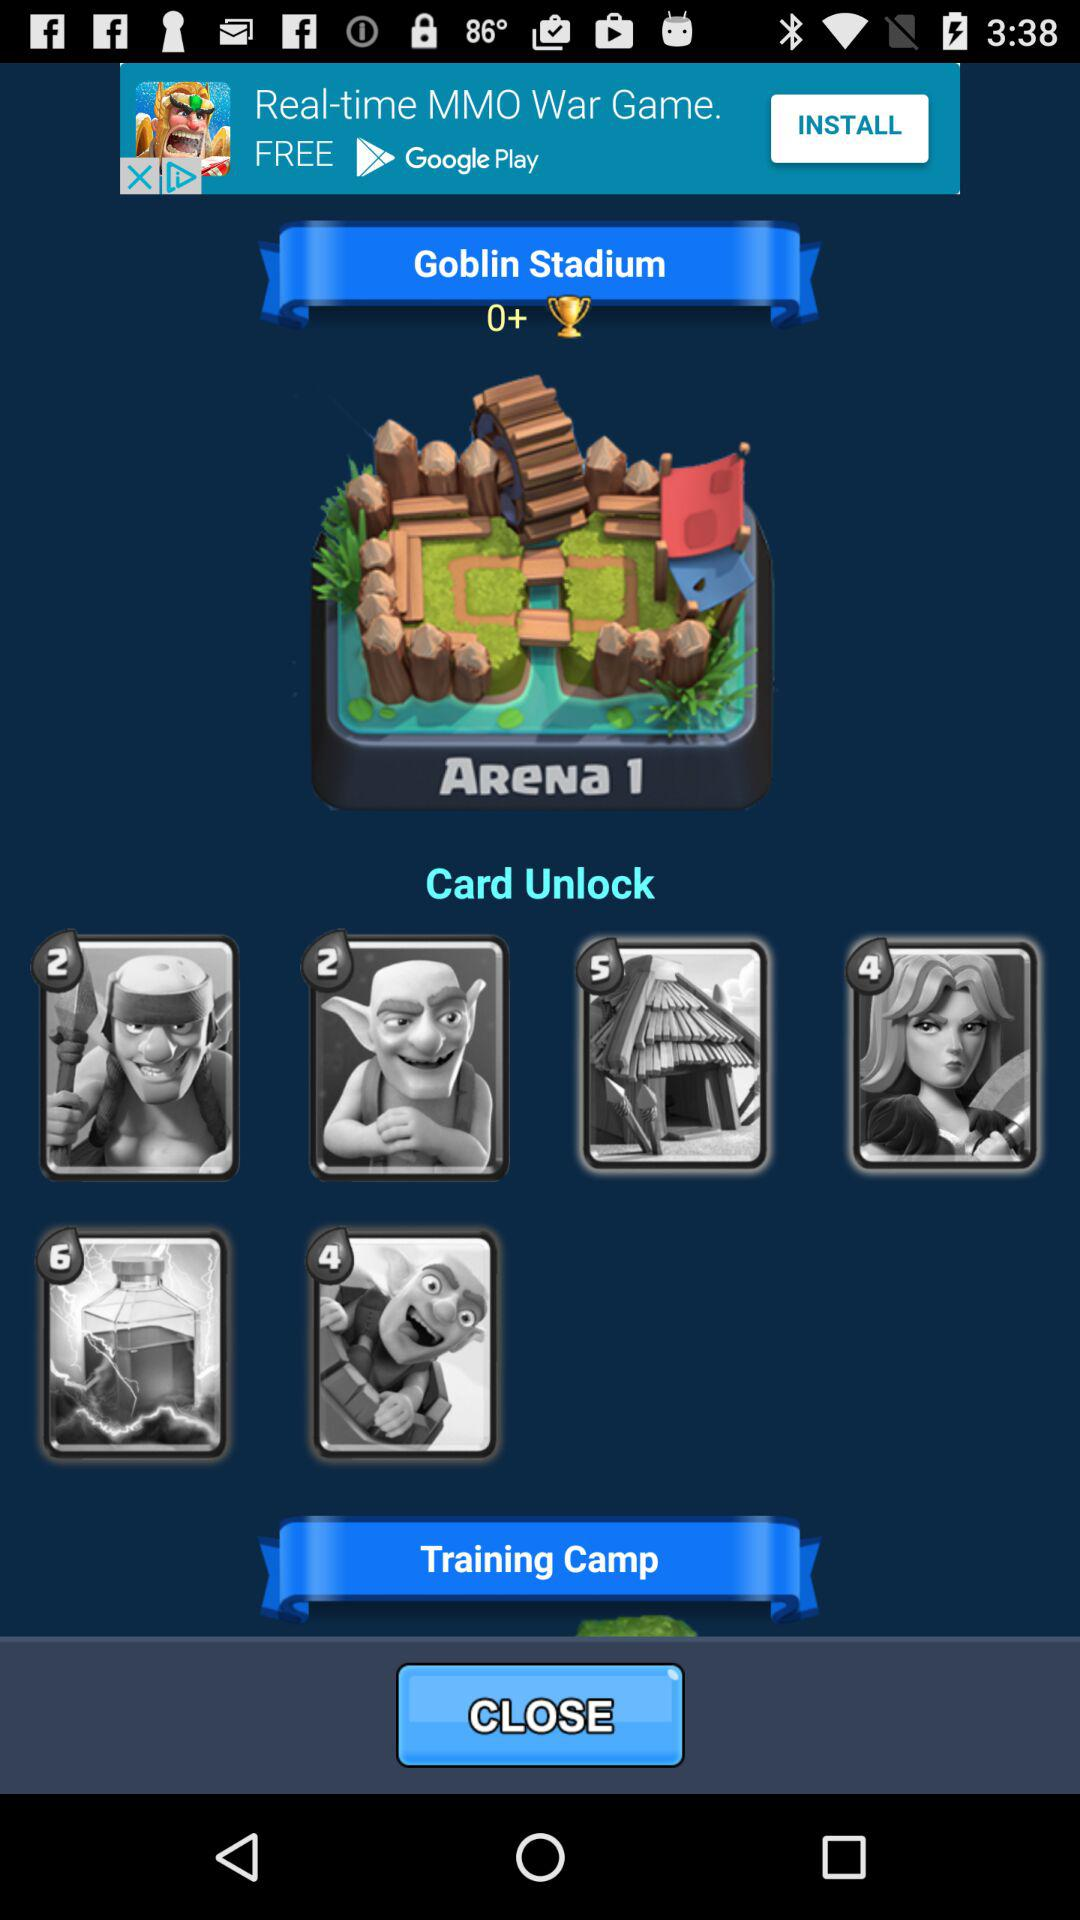What are the total points are there?
When the provided information is insufficient, respond with <no answer>. <no answer> 